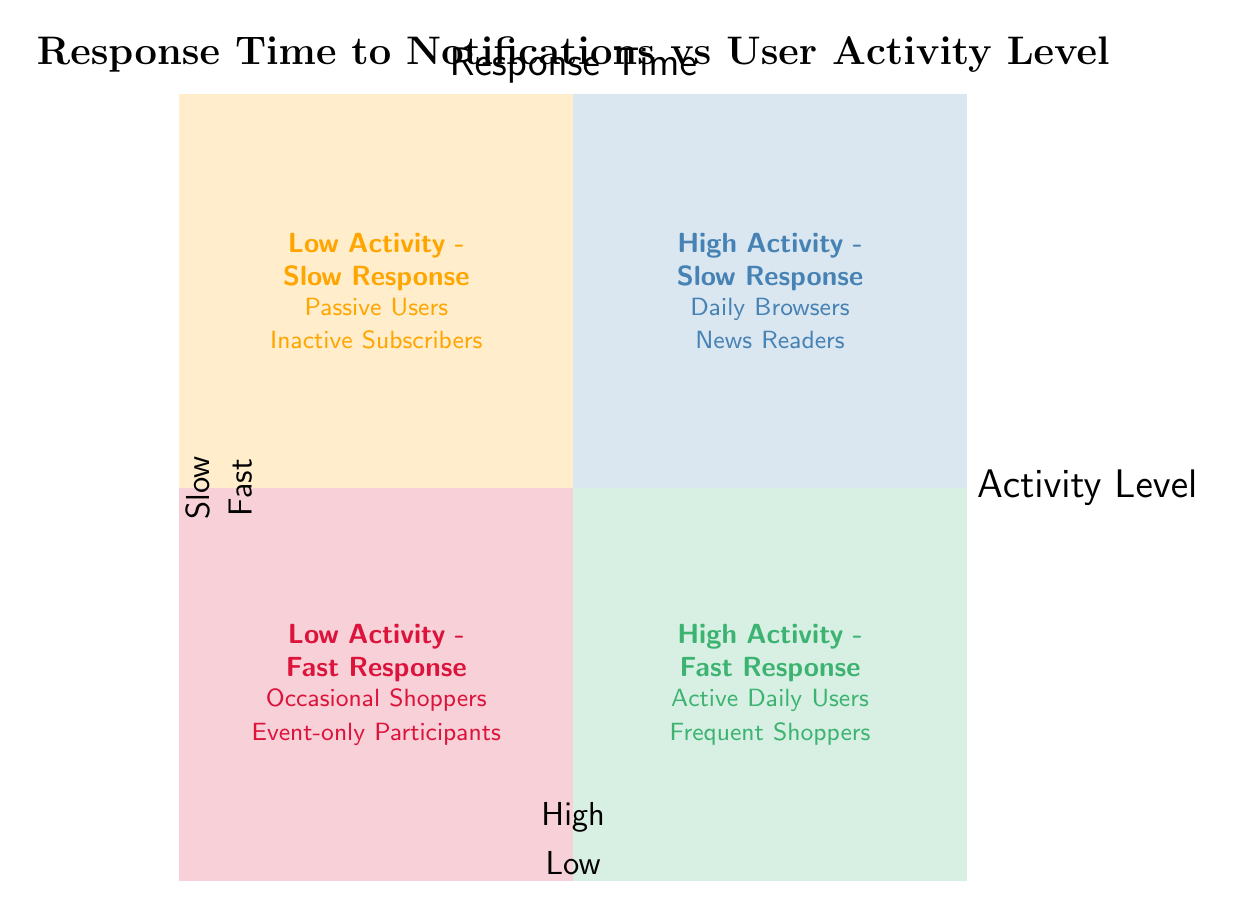What are the names of the quadrants in the chart? The chart has four quadrants: High Activity - Fast Response, High Activity - Slow Response, Low Activity - Fast Response, and Low Activity - Slow Response.
Answer: High Activity - Fast Response, High Activity - Slow Response, Low Activity - Fast Response, Low Activity - Slow Response Which quadrant represents users with high activity and slow response? In the diagram, the section located in the top right quadrant clearly labels High Activity - Slow Response, indicating those users who are active yet take time to respond.
Answer: High Activity - Slow Response What examples are given for the 'Low Activity - Fast Response' quadrant? The 'Low Activity - Fast Response' quadrant lists examples such as Occasional Shoppers and Event-only Participants, which define users who don't engage much with the platform but respond promptly to notifications.
Answer: Occasional Shoppers, Event-only Participants How many quadrants are there in the chart? The diagram displays four distinct quadrants that categorize users based on activity and response time, showing the classification of the user base.
Answer: Four Which quadrant includes 'Frequent Shoppers'? The 'Frequent Shoppers' example is included in the High Activity - Fast Response quadrant, which indicates their high engagement level along with quick responses to notifications.
Answer: High Activity - Fast Response What description is given for 'Low Activity - Slow Response'? The 'Low Activity - Slow Response' quadrant description states that it includes users who show low activity and have a slow response to push notifications, specifically highlighting their inactive nature.
Answer: Low Activity and Slow Response Identify the quadrant where 'Daily Browsers' are located. 'Daily Browsers' are located in the High Activity - Slow Response quadrant, reflecting users who are active on a daily basis but may take longer to respond to notifications.
Answer: High Activity - Slow Response What does the x-axis of the chart represent? The x-axis of the chart signifies Activity Level, which differentiates users based on how actively they engage with the service or notifications.
Answer: Activity Level 